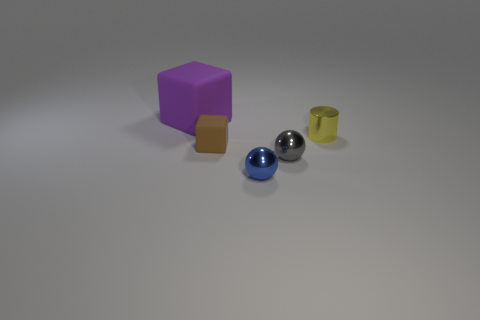How many tiny blue shiny things have the same shape as the tiny gray thing? 1 